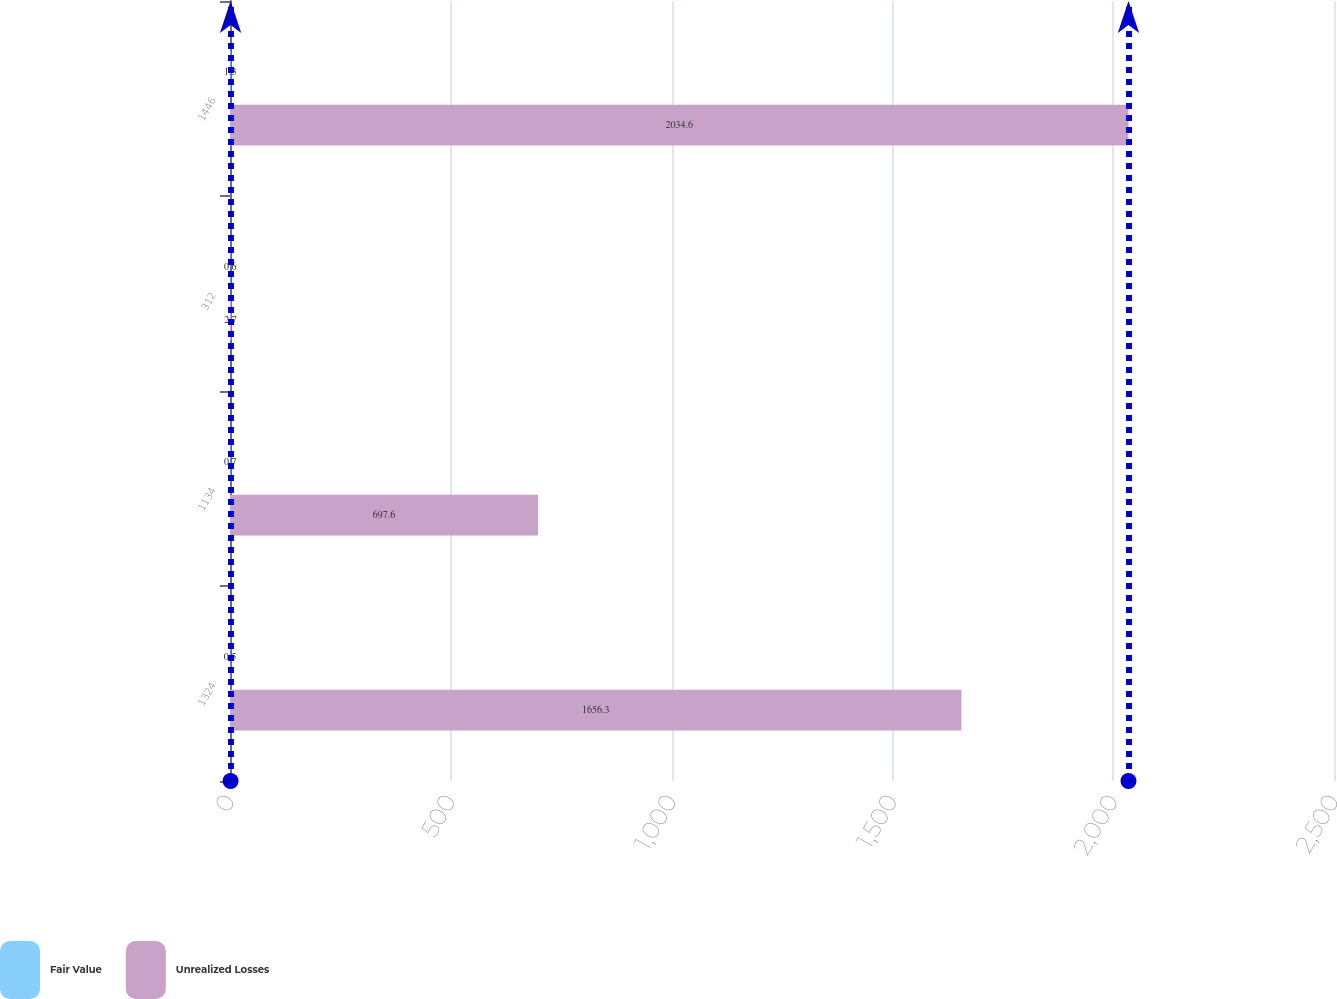<chart> <loc_0><loc_0><loc_500><loc_500><stacked_bar_chart><ecel><fcel>1324<fcel>1134<fcel>312<fcel>1446<nl><fcel>Fair Value<fcel>0.5<fcel>0.7<fcel>0.6<fcel>1.3<nl><fcel>Unrealized Losses<fcel>1656.3<fcel>697.6<fcel>2.7<fcel>2034.6<nl></chart> 